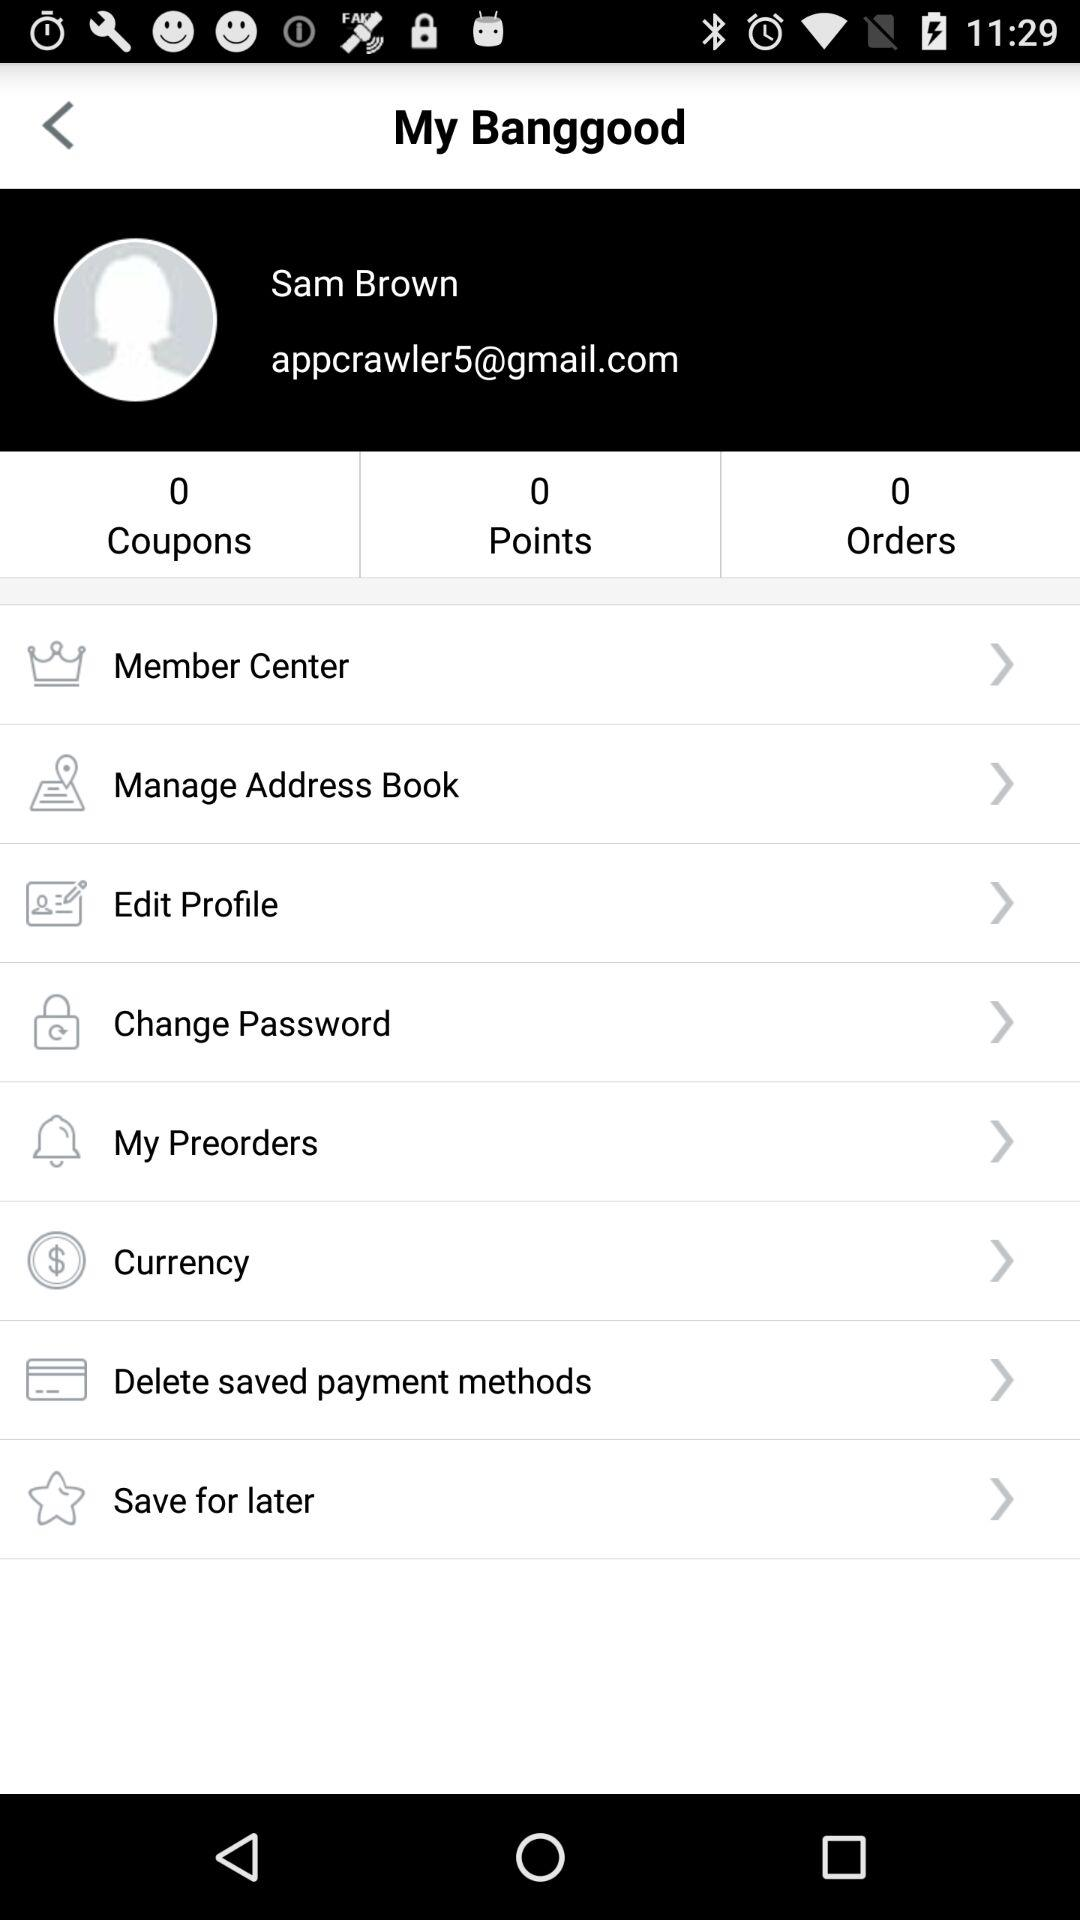What email address is mentioned? The mentioned email address is appcrawler5@gmail.com. 